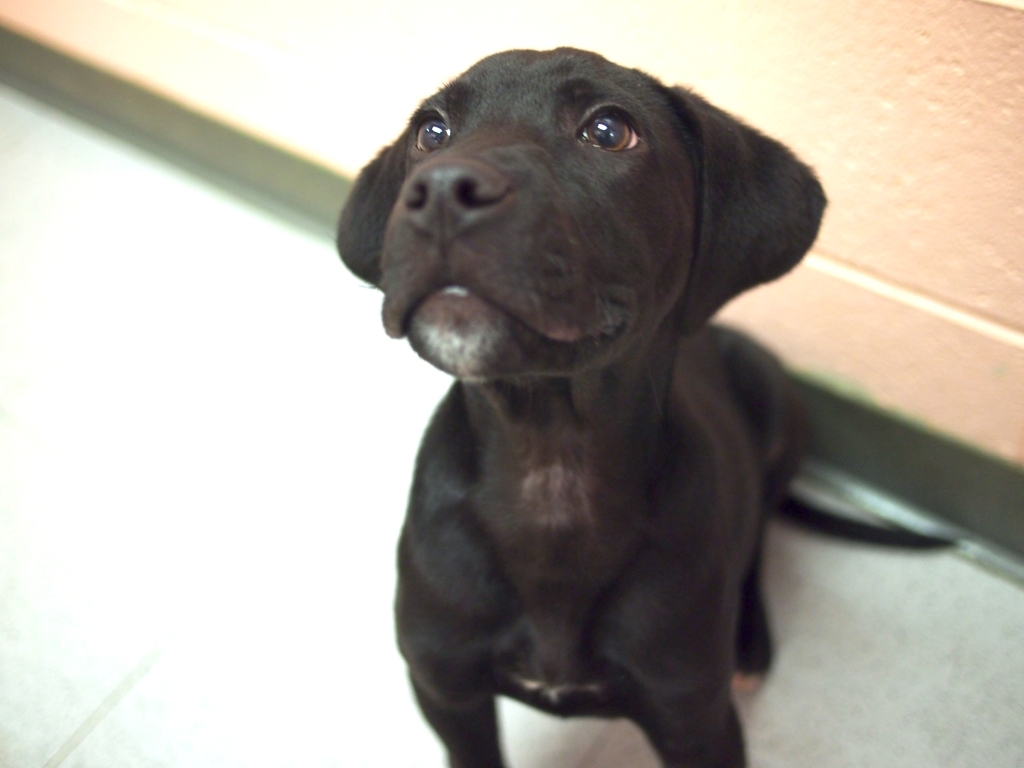What breed does this puppy resemble? This puppy's sleek black coat and facial structure suggest it could be a Labrador Retriever, which is known for these characteristics. 